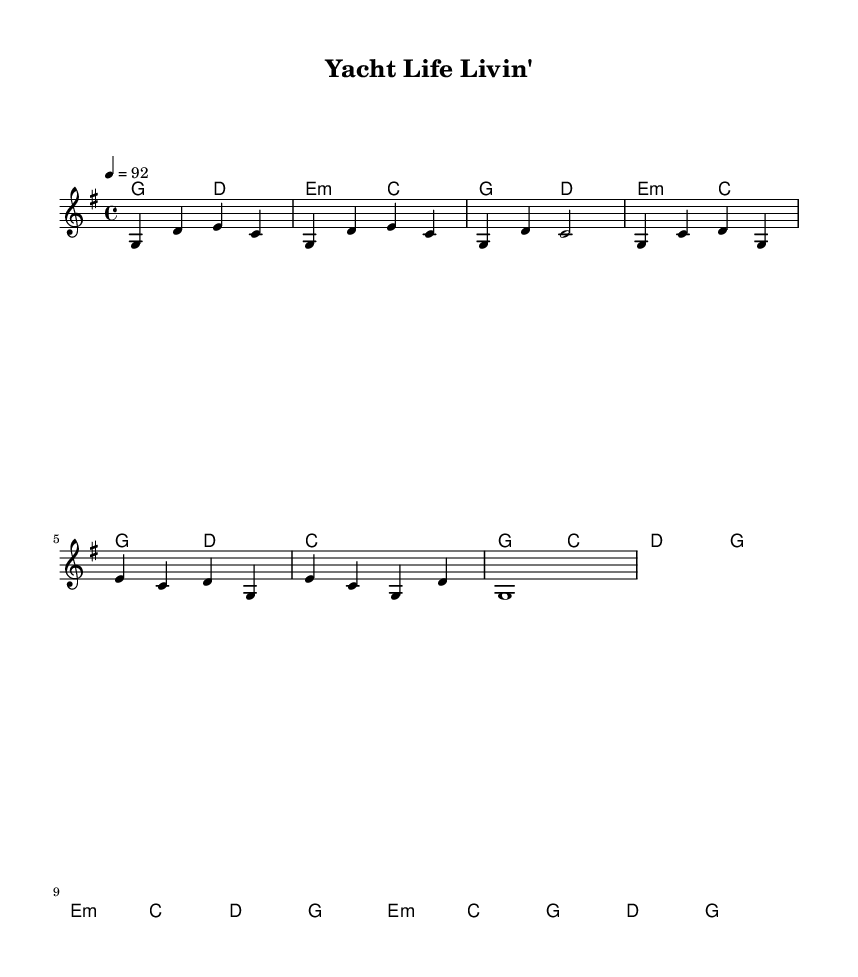What is the key signature of this music? The key signature is G major, which has one sharp (F#). This can be determined by looking at the key signature indicated at the beginning of the piece.
Answer: G major What is the time signature of this music? The time signature is 4/4, which is indicated at the beginning of the piece next to the key signature. This means there are four beats in a measure and the quarter note gets one beat.
Answer: 4/4 What is the tempo marking of this music? The tempo marking is 92 beats per minute, which is indicated at the start of the music under the tempo instruction. This indicates the speed at which the piece should be played.
Answer: 92 How many measures are in the chorus section? The chorus section contains four measures. By examining the notation provided, each line breaks down into sections, and the chorus is clearly delineated with four measures.
Answer: 4 What type of chord is indicated for the bridge? The bridge section starts with an E minor chord, denoted by "e:m." This type of chord is a minor chord built from the root note E, which is indicated in the harmonic section of the score.
Answer: E minor What are the last notes of the melody line? The last notes of the melody line are G, indicated as a whole note in the outro section. By analyzing the melody, it is the final note before the piece concludes.
Answer: G What is the harmonic progression for the first four measures? The harmonic progression for the first four measures consists of G major to D major and then to E minor and C major. By examining each chord indicated in the harmonies section for the intro, this sequence can be traced.
Answer: G, D, E minor, C 